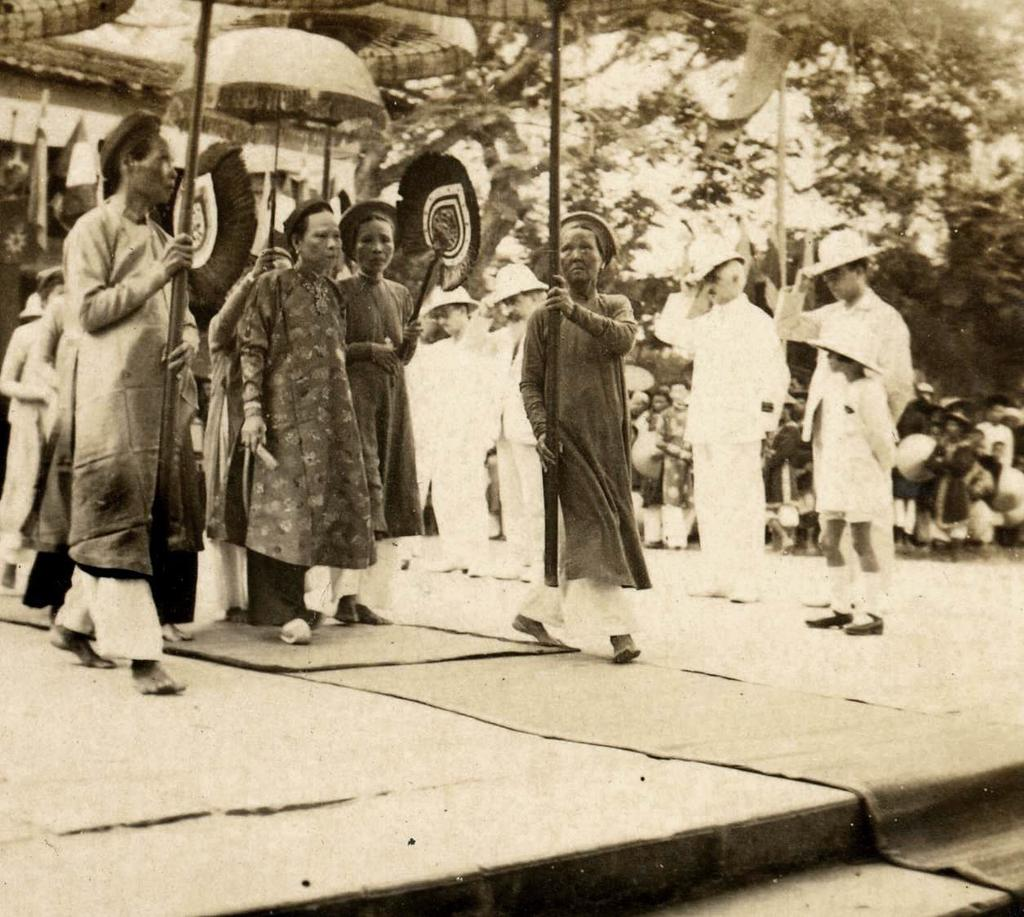What are the people in the image doing? There are people standing in the image. What are some people using to protect themselves from the elements? Some people are holding umbrellas in the image. What type of flooring is visible in the image? There is a carpet visible in the image. What type of pen is being used to write on the carpet in the image? There is no pen or writing on the carpet in the image. What flavor of jam is being served on the carpet in the image? There is no jam or food present on the carpet in the image. 